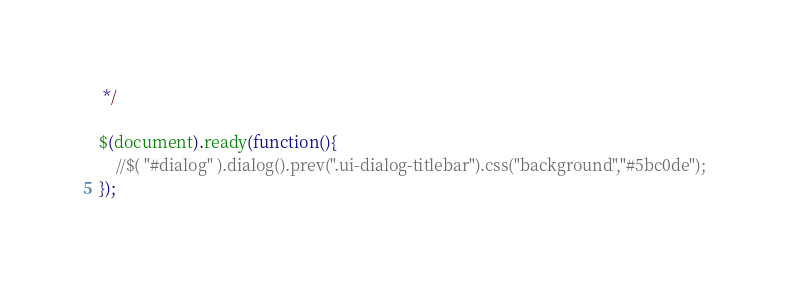<code> <loc_0><loc_0><loc_500><loc_500><_JavaScript_> */

$(document).ready(function(){
    //$( "#dialog" ).dialog().prev(".ui-dialog-titlebar").css("background","#5bc0de");
});</code> 